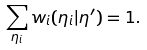Convert formula to latex. <formula><loc_0><loc_0><loc_500><loc_500>\sum _ { \eta _ { i } } w _ { i } ( \eta _ { i } | \eta ^ { \prime } ) = 1 .</formula> 